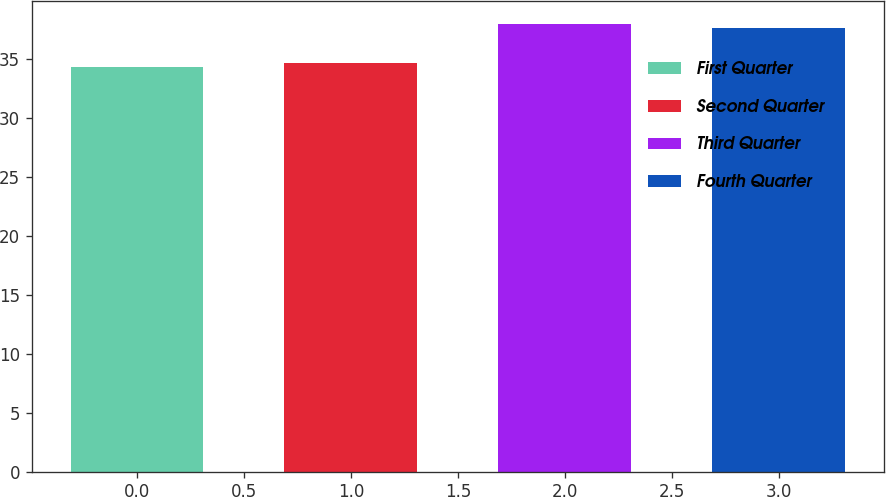Convert chart. <chart><loc_0><loc_0><loc_500><loc_500><bar_chart><fcel>First Quarter<fcel>Second Quarter<fcel>Third Quarter<fcel>Fourth Quarter<nl><fcel>34.37<fcel>34.74<fcel>38.05<fcel>37.65<nl></chart> 